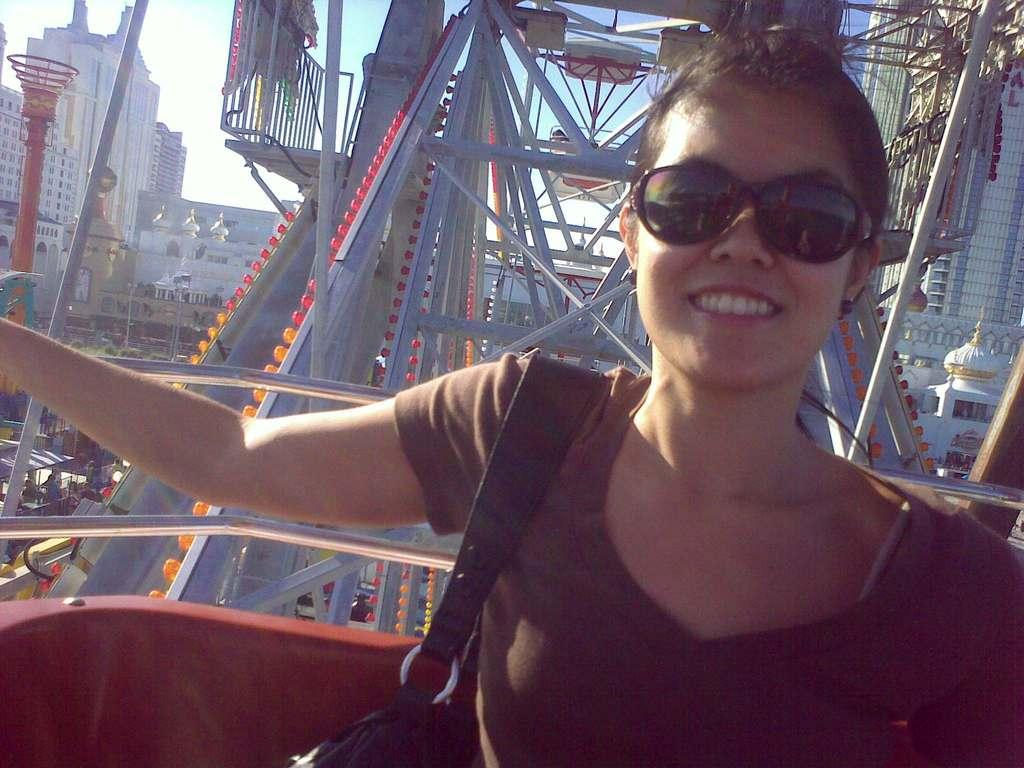What is the woman in the image doing? The woman is sitting in the image. What else can be seen in the image besides the woman? There are rods and many buildings visible in the image. What type of cream is the kitty licking in the image? There is no kitty or cream present in the image. 